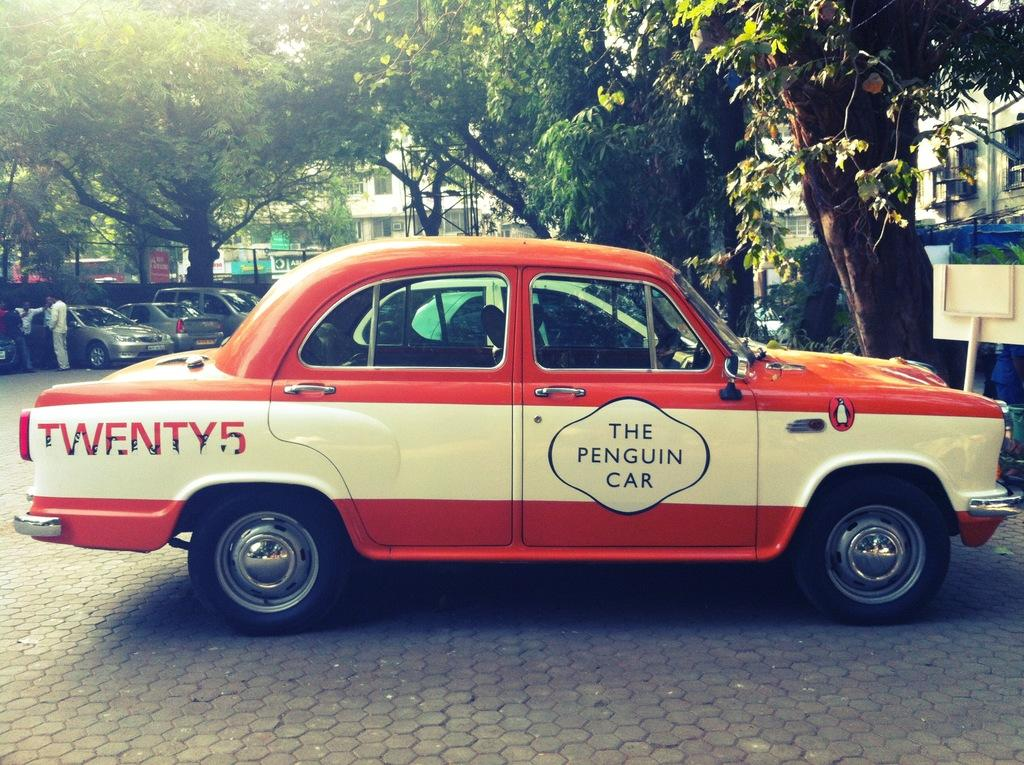What can be seen on the surface in the image? There are vehicles on the surface in the image. What type of natural elements are present in the image? There are trees in the image. What can be seen in the background of the image? There are buildings, people, and boards in the background of the image. How many clocks are hanging on the trees in the image? There are no clocks hanging on the trees in the image. What type of tools does the carpenter have in the image? There is no carpenter present in the image. What type of insurance is being advertised on the boards in the image? There is no insurance being advertised on the boards in the image. 